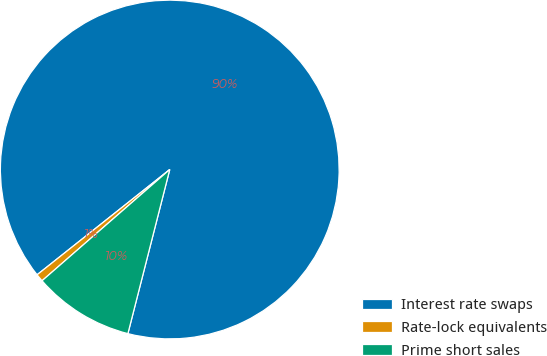Convert chart. <chart><loc_0><loc_0><loc_500><loc_500><pie_chart><fcel>Interest rate swaps<fcel>Rate-lock equivalents<fcel>Prime short sales<nl><fcel>89.65%<fcel>0.73%<fcel>9.62%<nl></chart> 